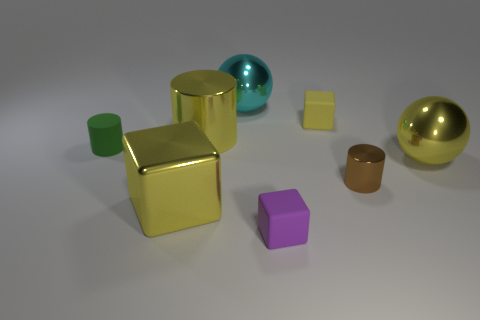Add 1 cyan metallic balls. How many objects exist? 9 Subtract all yellow matte cubes. How many cubes are left? 2 Subtract all balls. How many objects are left? 6 Subtract 3 cubes. How many cubes are left? 0 Subtract all yellow balls. Subtract all gray cylinders. How many balls are left? 1 Subtract all purple blocks. How many brown spheres are left? 0 Subtract all small red matte spheres. Subtract all cyan metallic spheres. How many objects are left? 7 Add 3 small rubber blocks. How many small rubber blocks are left? 5 Add 8 green rubber cylinders. How many green rubber cylinders exist? 9 Subtract all cyan balls. How many balls are left? 1 